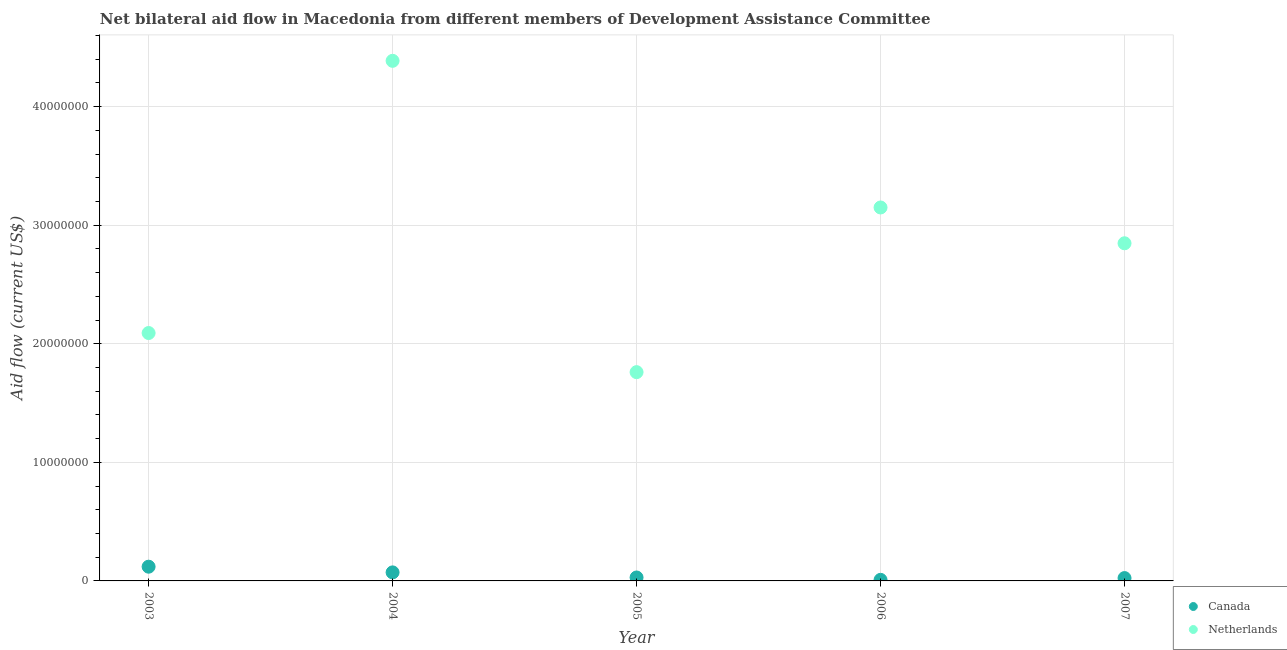Is the number of dotlines equal to the number of legend labels?
Offer a very short reply. Yes. What is the amount of aid given by canada in 2007?
Offer a very short reply. 2.40e+05. Across all years, what is the maximum amount of aid given by canada?
Your answer should be compact. 1.20e+06. Across all years, what is the minimum amount of aid given by canada?
Provide a succinct answer. 9.00e+04. In which year was the amount of aid given by netherlands minimum?
Your answer should be compact. 2005. What is the total amount of aid given by canada in the graph?
Your response must be concise. 2.54e+06. What is the difference between the amount of aid given by canada in 2006 and that in 2007?
Give a very brief answer. -1.50e+05. What is the difference between the amount of aid given by netherlands in 2003 and the amount of aid given by canada in 2006?
Keep it short and to the point. 2.08e+07. What is the average amount of aid given by canada per year?
Offer a very short reply. 5.08e+05. In the year 2004, what is the difference between the amount of aid given by netherlands and amount of aid given by canada?
Give a very brief answer. 4.32e+07. In how many years, is the amount of aid given by netherlands greater than 12000000 US$?
Provide a short and direct response. 5. What is the ratio of the amount of aid given by netherlands in 2003 to that in 2004?
Make the answer very short. 0.48. Is the amount of aid given by netherlands in 2004 less than that in 2006?
Your response must be concise. No. Is the difference between the amount of aid given by canada in 2005 and 2007 greater than the difference between the amount of aid given by netherlands in 2005 and 2007?
Provide a succinct answer. Yes. What is the difference between the highest and the second highest amount of aid given by canada?
Offer a terse response. 4.80e+05. What is the difference between the highest and the lowest amount of aid given by canada?
Make the answer very short. 1.11e+06. In how many years, is the amount of aid given by netherlands greater than the average amount of aid given by netherlands taken over all years?
Ensure brevity in your answer.  3. Is the sum of the amount of aid given by canada in 2004 and 2006 greater than the maximum amount of aid given by netherlands across all years?
Your answer should be compact. No. Does the amount of aid given by canada monotonically increase over the years?
Provide a short and direct response. No. Is the amount of aid given by canada strictly greater than the amount of aid given by netherlands over the years?
Your answer should be compact. No. How many dotlines are there?
Your answer should be very brief. 2. Where does the legend appear in the graph?
Provide a short and direct response. Bottom right. How are the legend labels stacked?
Offer a very short reply. Vertical. What is the title of the graph?
Provide a succinct answer. Net bilateral aid flow in Macedonia from different members of Development Assistance Committee. Does "constant 2005 US$" appear as one of the legend labels in the graph?
Your response must be concise. No. What is the Aid flow (current US$) in Canada in 2003?
Give a very brief answer. 1.20e+06. What is the Aid flow (current US$) of Netherlands in 2003?
Provide a succinct answer. 2.09e+07. What is the Aid flow (current US$) of Canada in 2004?
Keep it short and to the point. 7.20e+05. What is the Aid flow (current US$) in Netherlands in 2004?
Your response must be concise. 4.39e+07. What is the Aid flow (current US$) of Canada in 2005?
Keep it short and to the point. 2.90e+05. What is the Aid flow (current US$) in Netherlands in 2005?
Provide a succinct answer. 1.76e+07. What is the Aid flow (current US$) in Netherlands in 2006?
Your answer should be compact. 3.15e+07. What is the Aid flow (current US$) in Canada in 2007?
Your answer should be compact. 2.40e+05. What is the Aid flow (current US$) of Netherlands in 2007?
Give a very brief answer. 2.85e+07. Across all years, what is the maximum Aid flow (current US$) of Canada?
Provide a short and direct response. 1.20e+06. Across all years, what is the maximum Aid flow (current US$) of Netherlands?
Keep it short and to the point. 4.39e+07. Across all years, what is the minimum Aid flow (current US$) in Netherlands?
Keep it short and to the point. 1.76e+07. What is the total Aid flow (current US$) in Canada in the graph?
Give a very brief answer. 2.54e+06. What is the total Aid flow (current US$) of Netherlands in the graph?
Your answer should be very brief. 1.42e+08. What is the difference between the Aid flow (current US$) in Canada in 2003 and that in 2004?
Provide a short and direct response. 4.80e+05. What is the difference between the Aid flow (current US$) in Netherlands in 2003 and that in 2004?
Ensure brevity in your answer.  -2.30e+07. What is the difference between the Aid flow (current US$) of Canada in 2003 and that in 2005?
Your answer should be compact. 9.10e+05. What is the difference between the Aid flow (current US$) of Netherlands in 2003 and that in 2005?
Provide a succinct answer. 3.30e+06. What is the difference between the Aid flow (current US$) of Canada in 2003 and that in 2006?
Ensure brevity in your answer.  1.11e+06. What is the difference between the Aid flow (current US$) in Netherlands in 2003 and that in 2006?
Your answer should be compact. -1.06e+07. What is the difference between the Aid flow (current US$) of Canada in 2003 and that in 2007?
Make the answer very short. 9.60e+05. What is the difference between the Aid flow (current US$) in Netherlands in 2003 and that in 2007?
Your answer should be very brief. -7.57e+06. What is the difference between the Aid flow (current US$) in Netherlands in 2004 and that in 2005?
Offer a very short reply. 2.63e+07. What is the difference between the Aid flow (current US$) in Canada in 2004 and that in 2006?
Provide a succinct answer. 6.30e+05. What is the difference between the Aid flow (current US$) of Netherlands in 2004 and that in 2006?
Offer a terse response. 1.24e+07. What is the difference between the Aid flow (current US$) of Canada in 2004 and that in 2007?
Your answer should be very brief. 4.80e+05. What is the difference between the Aid flow (current US$) in Netherlands in 2004 and that in 2007?
Make the answer very short. 1.54e+07. What is the difference between the Aid flow (current US$) in Canada in 2005 and that in 2006?
Offer a terse response. 2.00e+05. What is the difference between the Aid flow (current US$) in Netherlands in 2005 and that in 2006?
Your answer should be very brief. -1.39e+07. What is the difference between the Aid flow (current US$) in Netherlands in 2005 and that in 2007?
Your answer should be very brief. -1.09e+07. What is the difference between the Aid flow (current US$) of Canada in 2006 and that in 2007?
Ensure brevity in your answer.  -1.50e+05. What is the difference between the Aid flow (current US$) in Netherlands in 2006 and that in 2007?
Ensure brevity in your answer.  3.02e+06. What is the difference between the Aid flow (current US$) of Canada in 2003 and the Aid flow (current US$) of Netherlands in 2004?
Give a very brief answer. -4.27e+07. What is the difference between the Aid flow (current US$) of Canada in 2003 and the Aid flow (current US$) of Netherlands in 2005?
Provide a short and direct response. -1.64e+07. What is the difference between the Aid flow (current US$) in Canada in 2003 and the Aid flow (current US$) in Netherlands in 2006?
Ensure brevity in your answer.  -3.03e+07. What is the difference between the Aid flow (current US$) of Canada in 2003 and the Aid flow (current US$) of Netherlands in 2007?
Give a very brief answer. -2.73e+07. What is the difference between the Aid flow (current US$) in Canada in 2004 and the Aid flow (current US$) in Netherlands in 2005?
Your response must be concise. -1.69e+07. What is the difference between the Aid flow (current US$) of Canada in 2004 and the Aid flow (current US$) of Netherlands in 2006?
Keep it short and to the point. -3.08e+07. What is the difference between the Aid flow (current US$) of Canada in 2004 and the Aid flow (current US$) of Netherlands in 2007?
Offer a terse response. -2.78e+07. What is the difference between the Aid flow (current US$) in Canada in 2005 and the Aid flow (current US$) in Netherlands in 2006?
Ensure brevity in your answer.  -3.12e+07. What is the difference between the Aid flow (current US$) in Canada in 2005 and the Aid flow (current US$) in Netherlands in 2007?
Provide a succinct answer. -2.82e+07. What is the difference between the Aid flow (current US$) of Canada in 2006 and the Aid flow (current US$) of Netherlands in 2007?
Make the answer very short. -2.84e+07. What is the average Aid flow (current US$) in Canada per year?
Make the answer very short. 5.08e+05. What is the average Aid flow (current US$) of Netherlands per year?
Offer a very short reply. 2.85e+07. In the year 2003, what is the difference between the Aid flow (current US$) in Canada and Aid flow (current US$) in Netherlands?
Your response must be concise. -1.97e+07. In the year 2004, what is the difference between the Aid flow (current US$) of Canada and Aid flow (current US$) of Netherlands?
Keep it short and to the point. -4.32e+07. In the year 2005, what is the difference between the Aid flow (current US$) of Canada and Aid flow (current US$) of Netherlands?
Make the answer very short. -1.73e+07. In the year 2006, what is the difference between the Aid flow (current US$) of Canada and Aid flow (current US$) of Netherlands?
Offer a very short reply. -3.14e+07. In the year 2007, what is the difference between the Aid flow (current US$) of Canada and Aid flow (current US$) of Netherlands?
Offer a terse response. -2.82e+07. What is the ratio of the Aid flow (current US$) in Canada in 2003 to that in 2004?
Offer a very short reply. 1.67. What is the ratio of the Aid flow (current US$) of Netherlands in 2003 to that in 2004?
Your answer should be very brief. 0.48. What is the ratio of the Aid flow (current US$) of Canada in 2003 to that in 2005?
Your answer should be very brief. 4.14. What is the ratio of the Aid flow (current US$) of Netherlands in 2003 to that in 2005?
Offer a terse response. 1.19. What is the ratio of the Aid flow (current US$) in Canada in 2003 to that in 2006?
Your answer should be very brief. 13.33. What is the ratio of the Aid flow (current US$) in Netherlands in 2003 to that in 2006?
Make the answer very short. 0.66. What is the ratio of the Aid flow (current US$) in Netherlands in 2003 to that in 2007?
Keep it short and to the point. 0.73. What is the ratio of the Aid flow (current US$) in Canada in 2004 to that in 2005?
Your answer should be very brief. 2.48. What is the ratio of the Aid flow (current US$) in Netherlands in 2004 to that in 2005?
Provide a short and direct response. 2.49. What is the ratio of the Aid flow (current US$) in Netherlands in 2004 to that in 2006?
Make the answer very short. 1.39. What is the ratio of the Aid flow (current US$) in Canada in 2004 to that in 2007?
Offer a very short reply. 3. What is the ratio of the Aid flow (current US$) in Netherlands in 2004 to that in 2007?
Ensure brevity in your answer.  1.54. What is the ratio of the Aid flow (current US$) of Canada in 2005 to that in 2006?
Ensure brevity in your answer.  3.22. What is the ratio of the Aid flow (current US$) of Netherlands in 2005 to that in 2006?
Keep it short and to the point. 0.56. What is the ratio of the Aid flow (current US$) in Canada in 2005 to that in 2007?
Ensure brevity in your answer.  1.21. What is the ratio of the Aid flow (current US$) of Netherlands in 2005 to that in 2007?
Your answer should be compact. 0.62. What is the ratio of the Aid flow (current US$) of Netherlands in 2006 to that in 2007?
Ensure brevity in your answer.  1.11. What is the difference between the highest and the second highest Aid flow (current US$) of Netherlands?
Your answer should be very brief. 1.24e+07. What is the difference between the highest and the lowest Aid flow (current US$) in Canada?
Your answer should be very brief. 1.11e+06. What is the difference between the highest and the lowest Aid flow (current US$) of Netherlands?
Make the answer very short. 2.63e+07. 